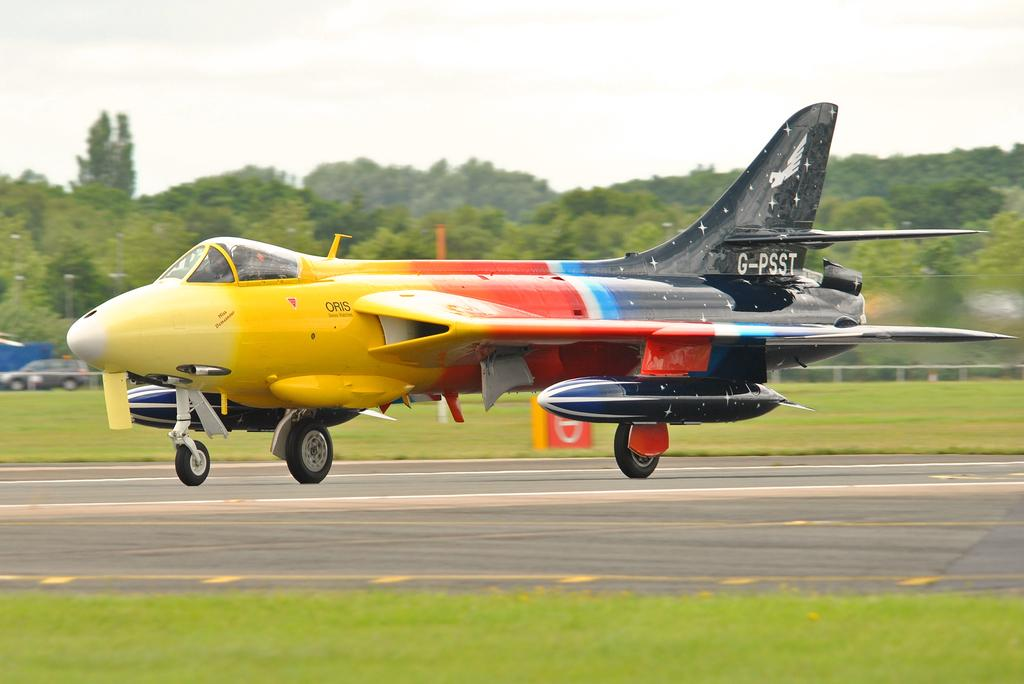<image>
Present a compact description of the photo's key features. A yellow, orange, blue and black airplane with call sign G-PSST. 